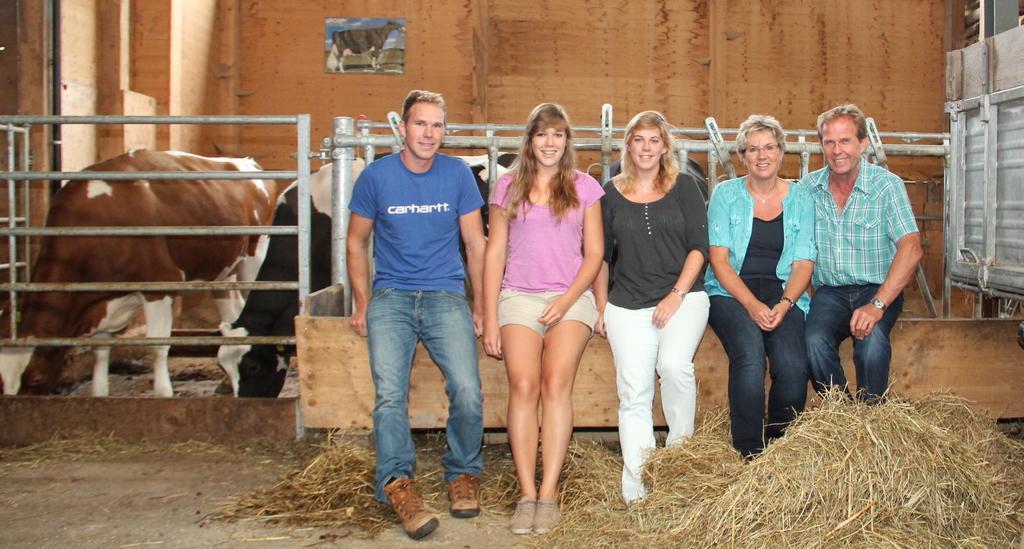Can you describe this image briefly? In the image we can see three women and two men, they are sitting and wearing clothes, some of them are wearing shoes and wrist watch. Here we can see dry grass, fence and cows. 